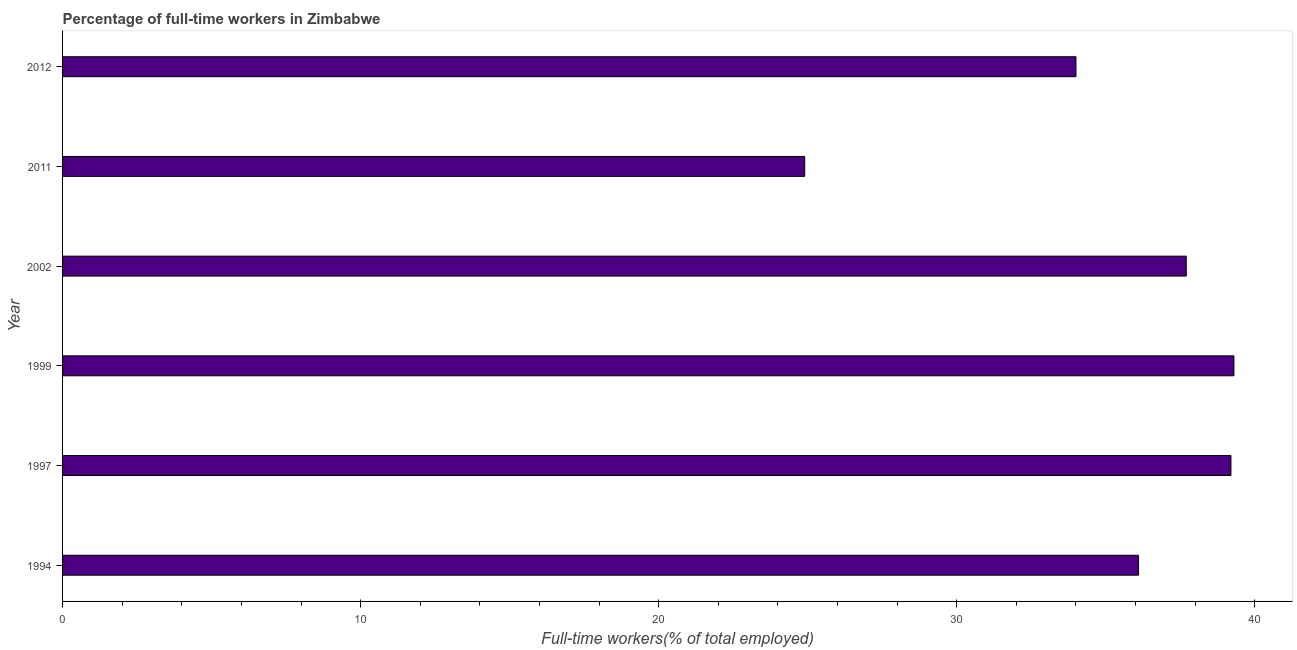Does the graph contain any zero values?
Give a very brief answer. No. Does the graph contain grids?
Ensure brevity in your answer.  No. What is the title of the graph?
Your answer should be compact. Percentage of full-time workers in Zimbabwe. What is the label or title of the X-axis?
Offer a very short reply. Full-time workers(% of total employed). What is the percentage of full-time workers in 2011?
Keep it short and to the point. 24.9. Across all years, what is the maximum percentage of full-time workers?
Ensure brevity in your answer.  39.3. Across all years, what is the minimum percentage of full-time workers?
Keep it short and to the point. 24.9. What is the sum of the percentage of full-time workers?
Provide a short and direct response. 211.2. What is the difference between the percentage of full-time workers in 1994 and 2011?
Keep it short and to the point. 11.2. What is the average percentage of full-time workers per year?
Your response must be concise. 35.2. What is the median percentage of full-time workers?
Make the answer very short. 36.9. Do a majority of the years between 1994 and 1997 (inclusive) have percentage of full-time workers greater than 4 %?
Your response must be concise. Yes. What is the ratio of the percentage of full-time workers in 1997 to that in 2012?
Your response must be concise. 1.15. Is the difference between the percentage of full-time workers in 1997 and 1999 greater than the difference between any two years?
Your answer should be very brief. No. What is the difference between the highest and the second highest percentage of full-time workers?
Your answer should be very brief. 0.1. What is the difference between the highest and the lowest percentage of full-time workers?
Make the answer very short. 14.4. Are all the bars in the graph horizontal?
Your answer should be very brief. Yes. How many years are there in the graph?
Provide a succinct answer. 6. What is the difference between two consecutive major ticks on the X-axis?
Ensure brevity in your answer.  10. Are the values on the major ticks of X-axis written in scientific E-notation?
Your response must be concise. No. What is the Full-time workers(% of total employed) of 1994?
Your answer should be compact. 36.1. What is the Full-time workers(% of total employed) of 1997?
Your answer should be compact. 39.2. What is the Full-time workers(% of total employed) of 1999?
Your answer should be compact. 39.3. What is the Full-time workers(% of total employed) of 2002?
Your response must be concise. 37.7. What is the Full-time workers(% of total employed) in 2011?
Offer a very short reply. 24.9. What is the difference between the Full-time workers(% of total employed) in 1994 and 2002?
Offer a terse response. -1.6. What is the difference between the Full-time workers(% of total employed) in 1999 and 2011?
Your response must be concise. 14.4. What is the difference between the Full-time workers(% of total employed) in 2002 and 2011?
Ensure brevity in your answer.  12.8. What is the ratio of the Full-time workers(% of total employed) in 1994 to that in 1997?
Provide a short and direct response. 0.92. What is the ratio of the Full-time workers(% of total employed) in 1994 to that in 1999?
Offer a terse response. 0.92. What is the ratio of the Full-time workers(% of total employed) in 1994 to that in 2002?
Your answer should be very brief. 0.96. What is the ratio of the Full-time workers(% of total employed) in 1994 to that in 2011?
Keep it short and to the point. 1.45. What is the ratio of the Full-time workers(% of total employed) in 1994 to that in 2012?
Your answer should be very brief. 1.06. What is the ratio of the Full-time workers(% of total employed) in 1997 to that in 1999?
Your answer should be very brief. 1. What is the ratio of the Full-time workers(% of total employed) in 1997 to that in 2002?
Ensure brevity in your answer.  1.04. What is the ratio of the Full-time workers(% of total employed) in 1997 to that in 2011?
Your answer should be compact. 1.57. What is the ratio of the Full-time workers(% of total employed) in 1997 to that in 2012?
Offer a terse response. 1.15. What is the ratio of the Full-time workers(% of total employed) in 1999 to that in 2002?
Give a very brief answer. 1.04. What is the ratio of the Full-time workers(% of total employed) in 1999 to that in 2011?
Your answer should be very brief. 1.58. What is the ratio of the Full-time workers(% of total employed) in 1999 to that in 2012?
Keep it short and to the point. 1.16. What is the ratio of the Full-time workers(% of total employed) in 2002 to that in 2011?
Offer a very short reply. 1.51. What is the ratio of the Full-time workers(% of total employed) in 2002 to that in 2012?
Provide a succinct answer. 1.11. What is the ratio of the Full-time workers(% of total employed) in 2011 to that in 2012?
Provide a succinct answer. 0.73. 